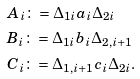Convert formula to latex. <formula><loc_0><loc_0><loc_500><loc_500>& A _ { i } \colon = \Delta _ { 1 i } a _ { i } \Delta _ { 2 i } \\ & B _ { i } \colon = \Delta _ { 1 i } b _ { i } \Delta _ { 2 , i + 1 } \\ & C _ { i } \colon = \Delta _ { 1 , i + 1 } c _ { i } \Delta _ { 2 i } .</formula> 